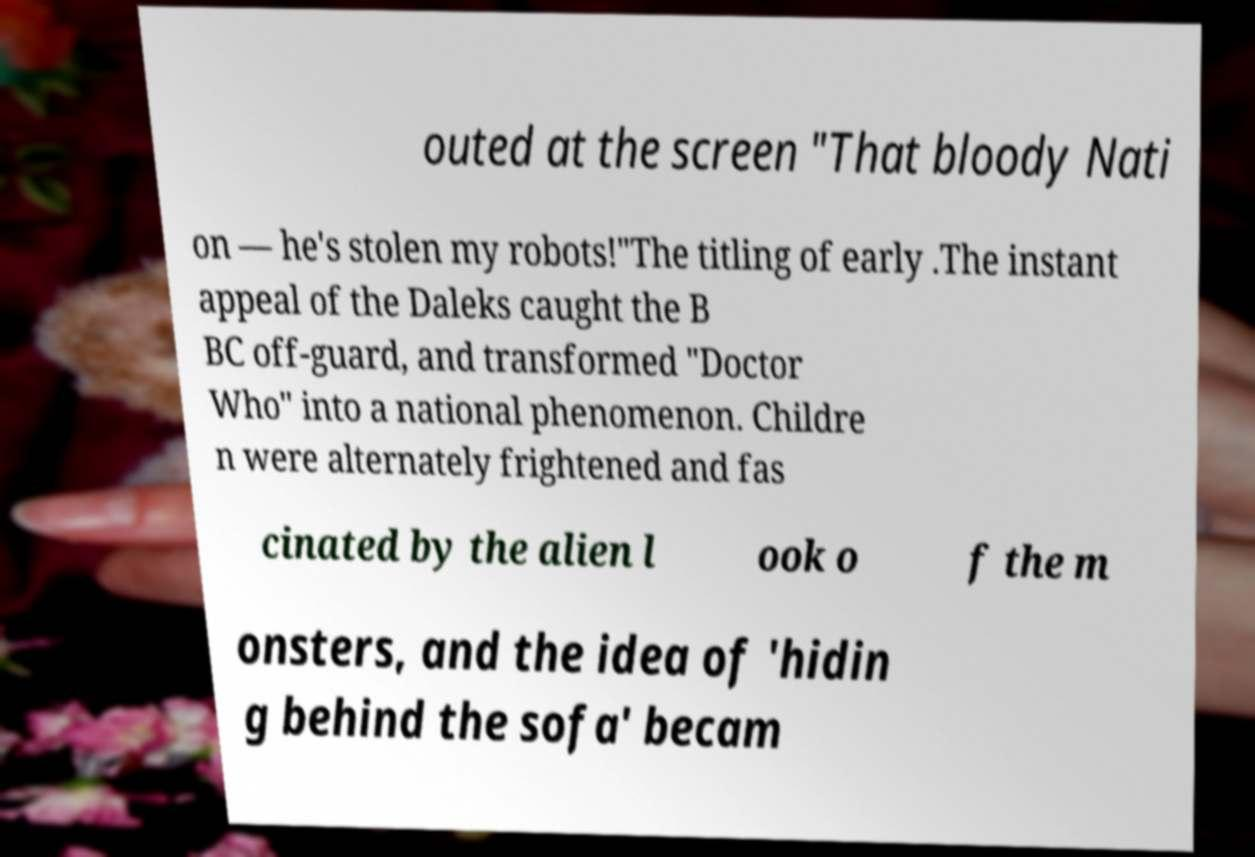Please read and relay the text visible in this image. What does it say? outed at the screen "That bloody Nati on — he's stolen my robots!"The titling of early .The instant appeal of the Daleks caught the B BC off-guard, and transformed "Doctor Who" into a national phenomenon. Childre n were alternately frightened and fas cinated by the alien l ook o f the m onsters, and the idea of 'hidin g behind the sofa' becam 